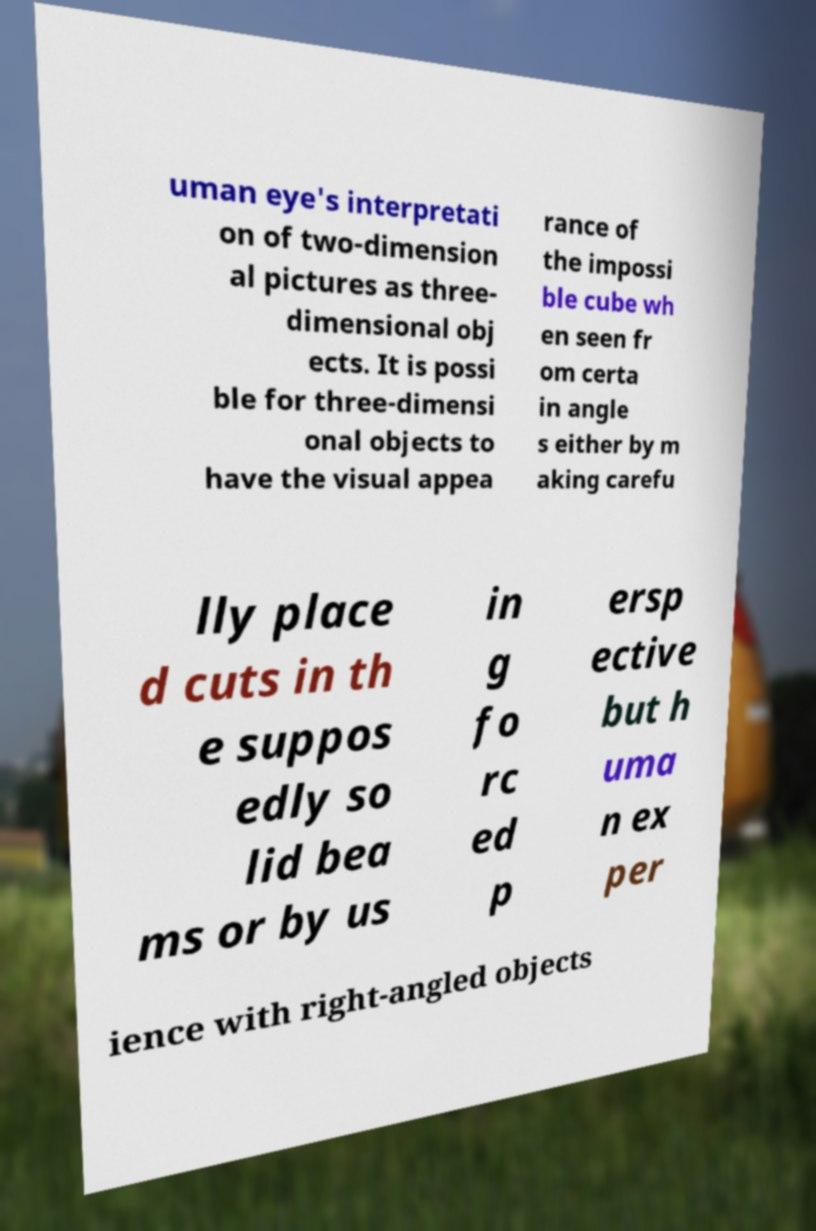There's text embedded in this image that I need extracted. Can you transcribe it verbatim? uman eye's interpretati on of two-dimension al pictures as three- dimensional obj ects. It is possi ble for three-dimensi onal objects to have the visual appea rance of the impossi ble cube wh en seen fr om certa in angle s either by m aking carefu lly place d cuts in th e suppos edly so lid bea ms or by us in g fo rc ed p ersp ective but h uma n ex per ience with right-angled objects 